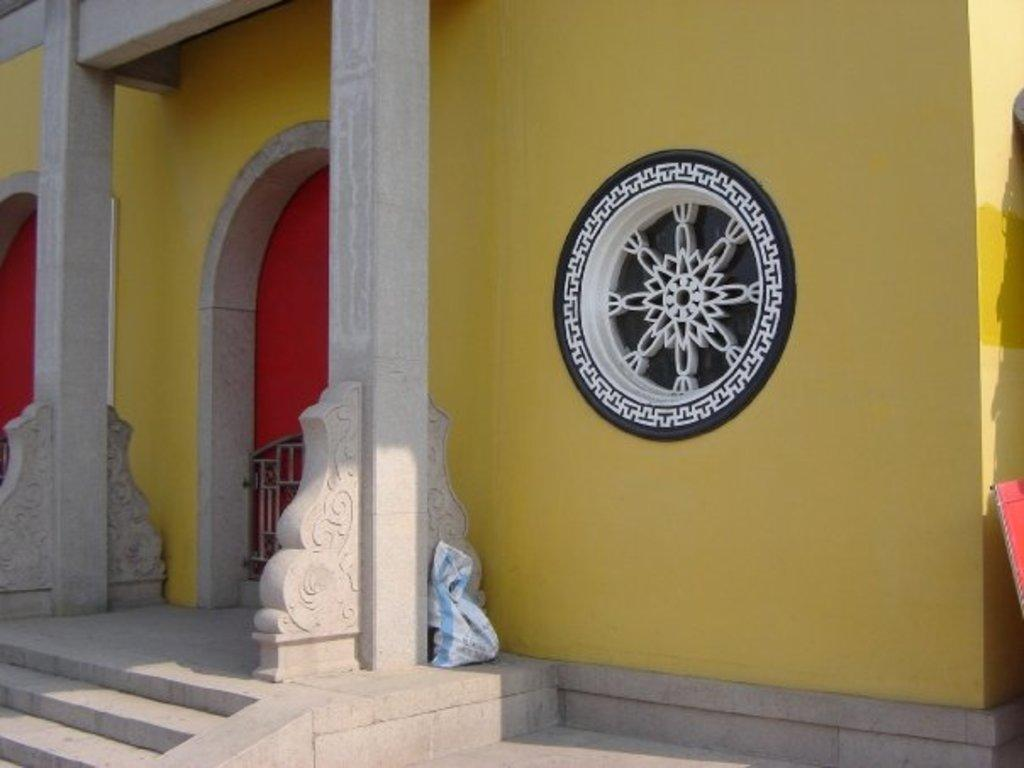What type of structure is visible in the image? There is a building in the image. Can you describe the design on the wall of the building? There is a big yellow wall with a flower design in the image. What is the entrance to the building like? There is a small gate in the image. How many doors can be seen on the building? There are two red color doors in the image. What can be found on the surface of the building? There are objects on the surface in the image. How many loaves of bread are being observed by the dogs in the image? There are no loaves of bread or dogs present in the image. 